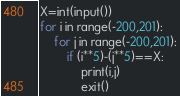Convert code to text. <code><loc_0><loc_0><loc_500><loc_500><_Python_>X=int(input())
for i in range(-200,201):
    for j in range(-200,201):
        if (i**5)-(j**5)==X:
            print(i,j)
            exit()</code> 